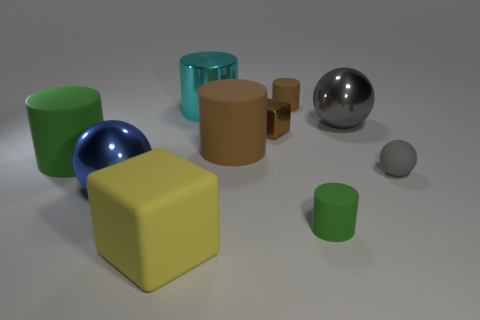The matte thing to the left of the large ball that is in front of the green matte cylinder that is to the left of the tiny green rubber cylinder is what shape?
Offer a very short reply. Cylinder. What number of other things are made of the same material as the large cyan cylinder?
Offer a terse response. 3. How many things are big rubber cylinders left of the big blue metal object or gray metal objects?
Keep it short and to the point. 2. There is a matte object that is on the left side of the big rubber cube that is in front of the large green rubber cylinder; what shape is it?
Give a very brief answer. Cylinder. There is a green matte thing that is to the right of the large cyan object; is it the same shape as the blue object?
Your response must be concise. No. What color is the tiny rubber cylinder that is on the left side of the tiny green cylinder?
Keep it short and to the point. Brown. What number of cubes are metal objects or tiny brown matte things?
Offer a terse response. 1. What is the size of the green object that is right of the metallic block that is left of the tiny gray sphere?
Your response must be concise. Small. There is a tiny block; does it have the same color as the big ball that is left of the small green rubber thing?
Offer a terse response. No. There is a big green rubber object; what number of large yellow cubes are to the right of it?
Make the answer very short. 1. 